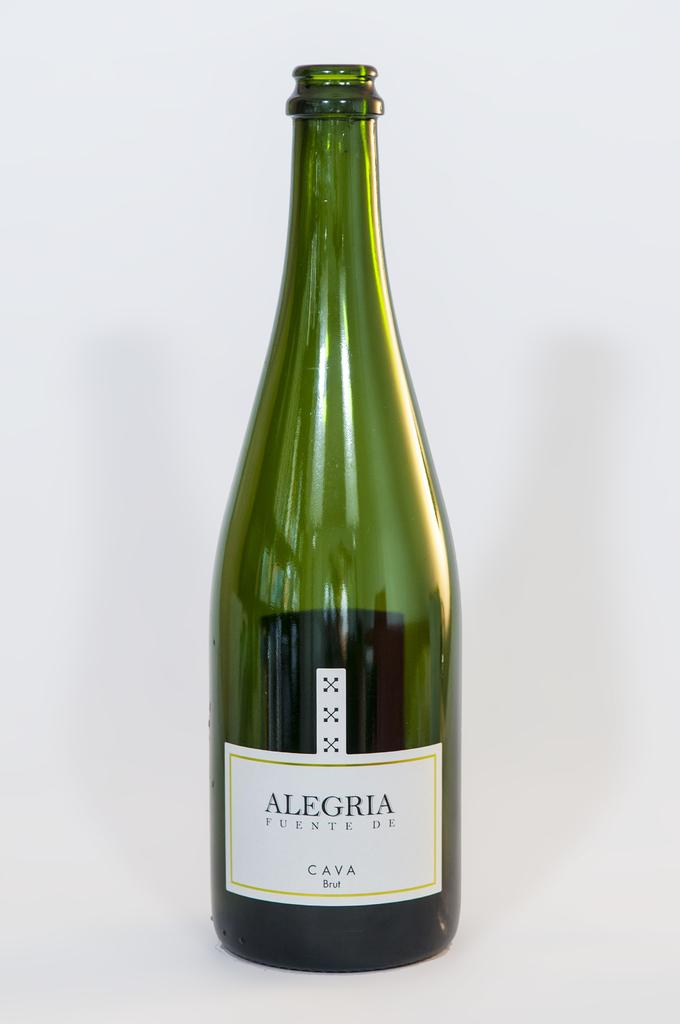<image>
Present a compact description of the photo's key features. A bottle of Alegria Fuente de Cava Brut sits with its cork off. 